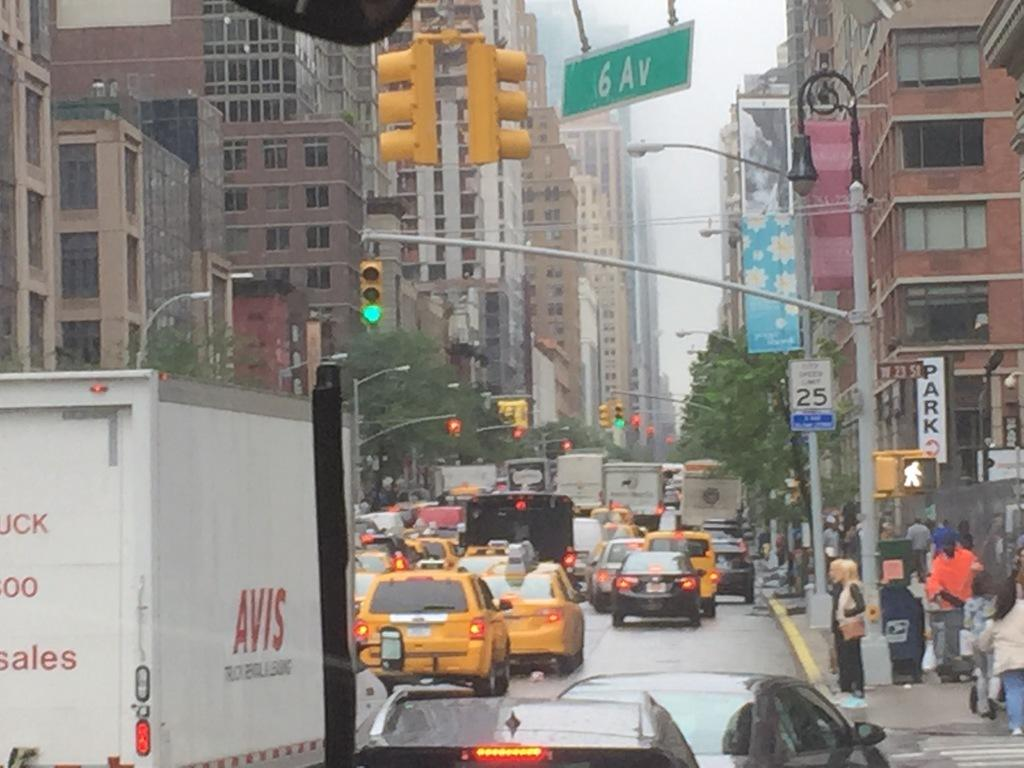<image>
Share a concise interpretation of the image provided. A lot of different vehicles are driving down 6 av with the sign visible at the top. 